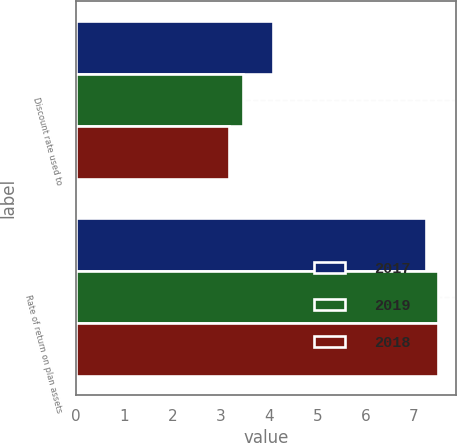<chart> <loc_0><loc_0><loc_500><loc_500><stacked_bar_chart><ecel><fcel>Discount rate used to<fcel>Rate of return on plan assets<nl><fcel>2017<fcel>4.09<fcel>7.25<nl><fcel>2019<fcel>3.46<fcel>7.5<nl><fcel>2018<fcel>3.18<fcel>7.5<nl></chart> 